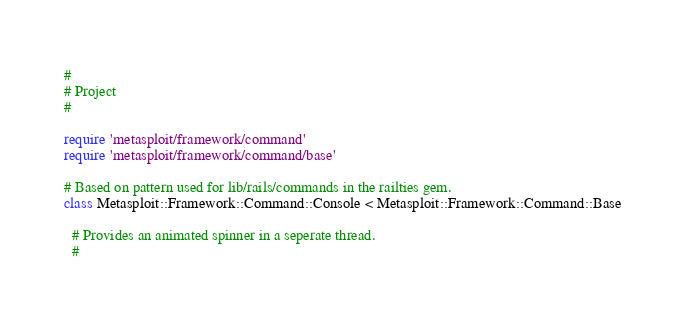<code> <loc_0><loc_0><loc_500><loc_500><_Ruby_>#
# Project
#

require 'metasploit/framework/command'
require 'metasploit/framework/command/base'

# Based on pattern used for lib/rails/commands in the railties gem.
class Metasploit::Framework::Command::Console < Metasploit::Framework::Command::Base

  # Provides an animated spinner in a seperate thread.
  #</code> 